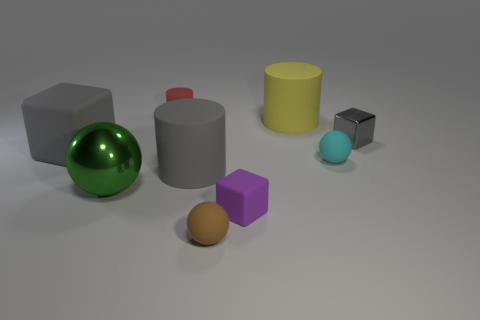Add 1 small yellow cubes. How many objects exist? 10 Subtract all cubes. How many objects are left? 6 Subtract all cyan metallic blocks. Subtract all metal things. How many objects are left? 7 Add 1 large metal spheres. How many large metal spheres are left? 2 Add 7 blue matte cubes. How many blue matte cubes exist? 7 Subtract 0 red balls. How many objects are left? 9 